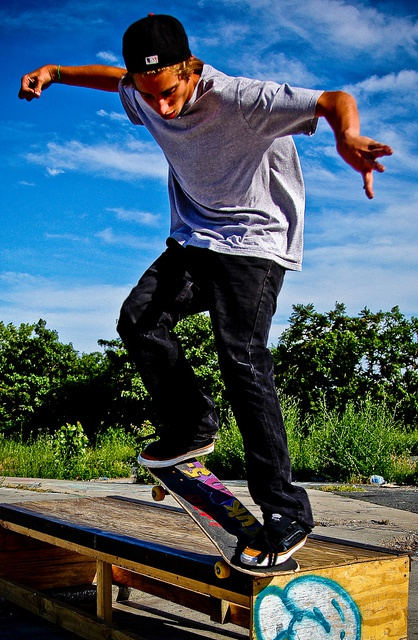Describe the objects in this image and their specific colors. I can see people in navy, black, gray, and lightgray tones and skateboard in navy, black, gray, maroon, and darkgray tones in this image. 